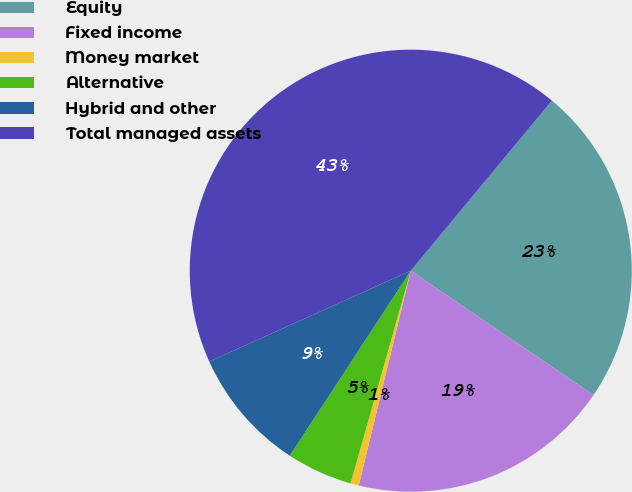<chart> <loc_0><loc_0><loc_500><loc_500><pie_chart><fcel>Equity<fcel>Fixed income<fcel>Money market<fcel>Alternative<fcel>Hybrid and other<fcel>Total managed assets<nl><fcel>23.49%<fcel>19.27%<fcel>0.61%<fcel>4.83%<fcel>9.04%<fcel>42.77%<nl></chart> 